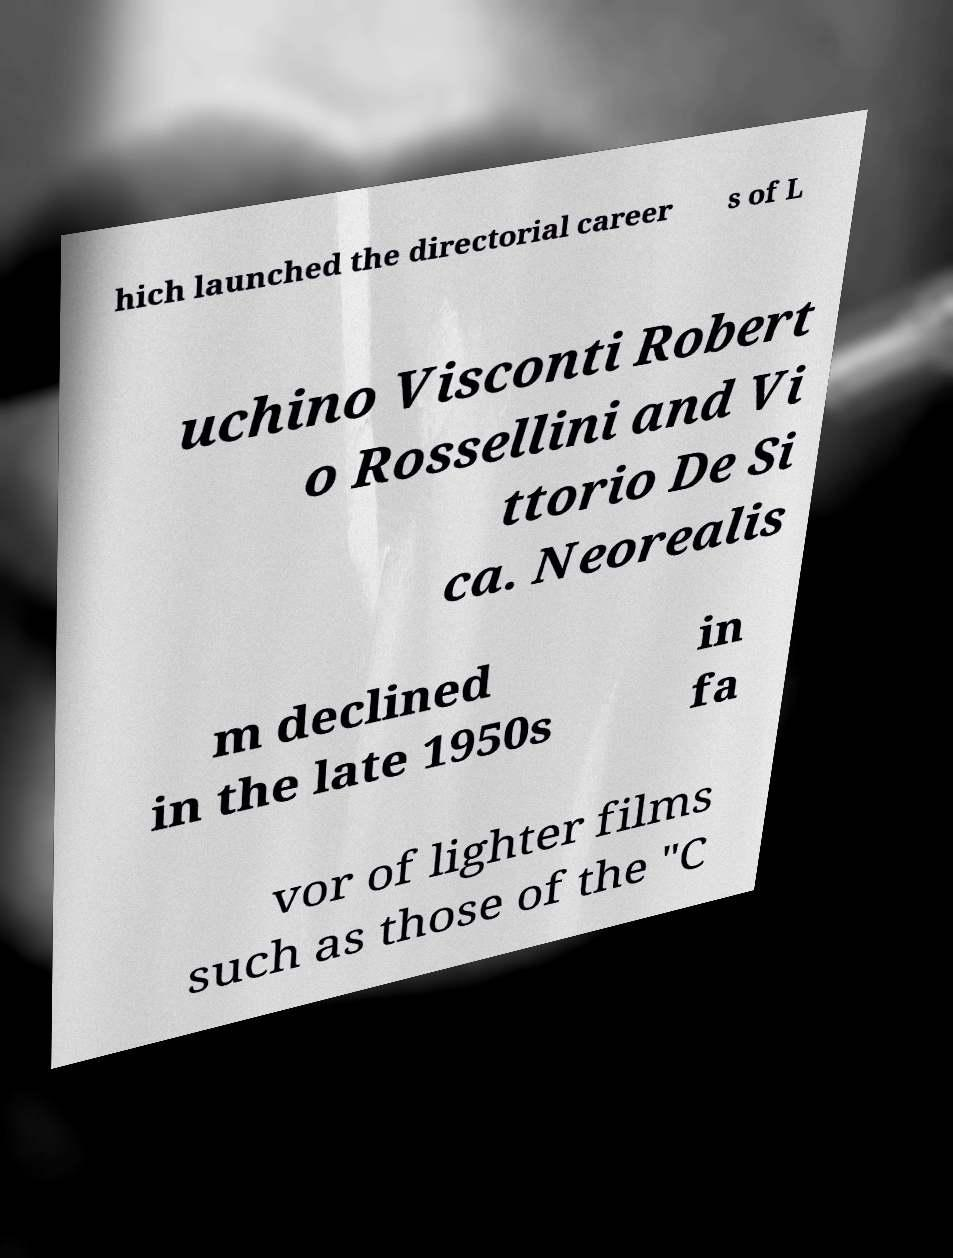Could you extract and type out the text from this image? hich launched the directorial career s of L uchino Visconti Robert o Rossellini and Vi ttorio De Si ca. Neorealis m declined in the late 1950s in fa vor of lighter films such as those of the "C 